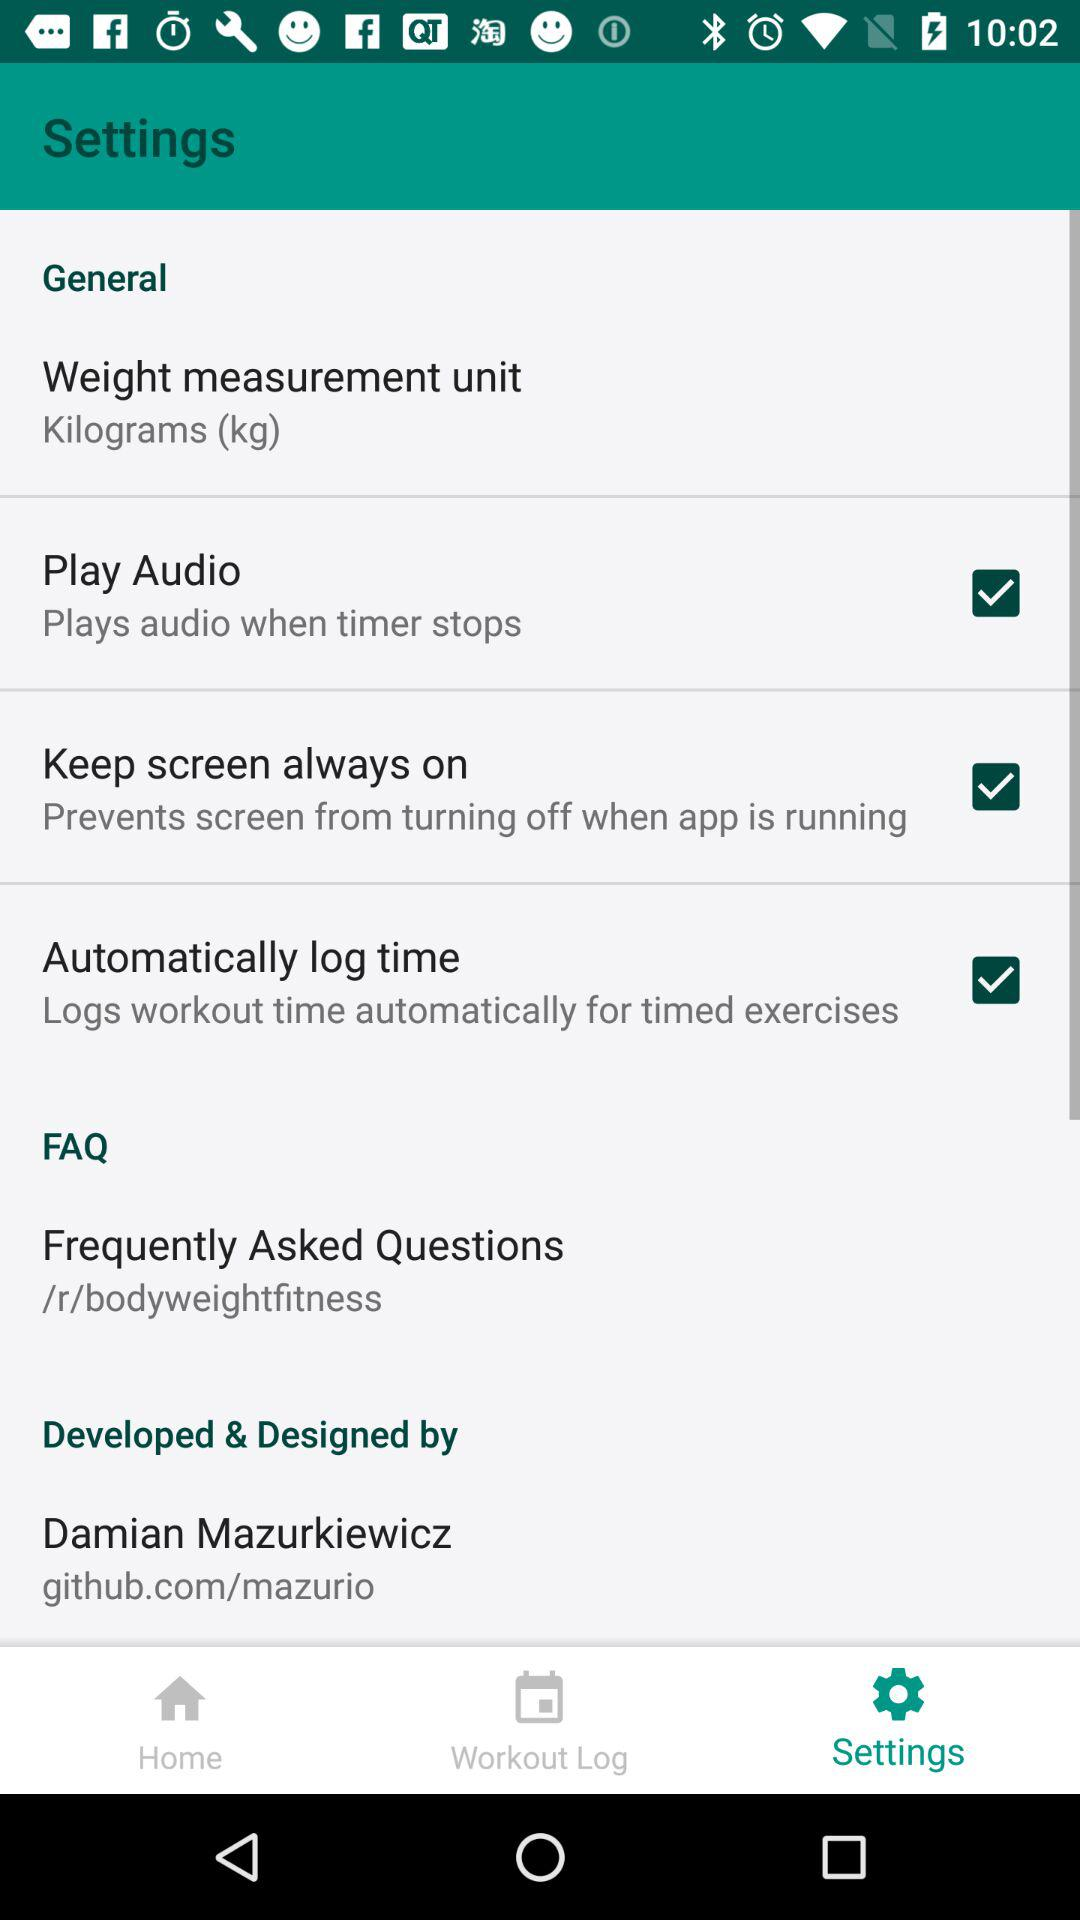What is the type of setting? The type of setting is General. 